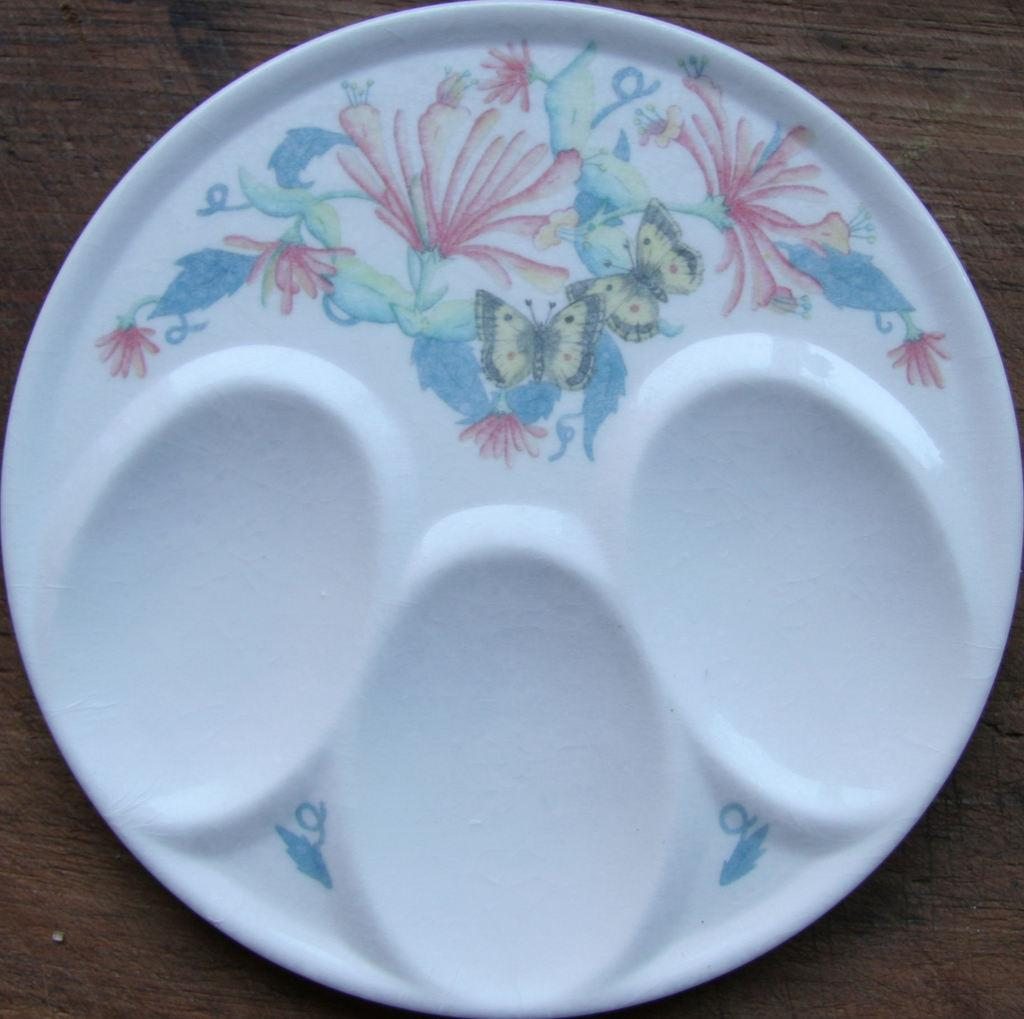What is present on the wooden surface in the image? There is a plate on the wooden surface. What is depicted on the plate? There is some art visible on the plate. What caption is written below the art on the plate? There is no caption visible on the plate in the image. Can you tell me what type of pet is sitting next to the plate? There is no pet present in the image; it only features a plate with art on a wooden surface. 